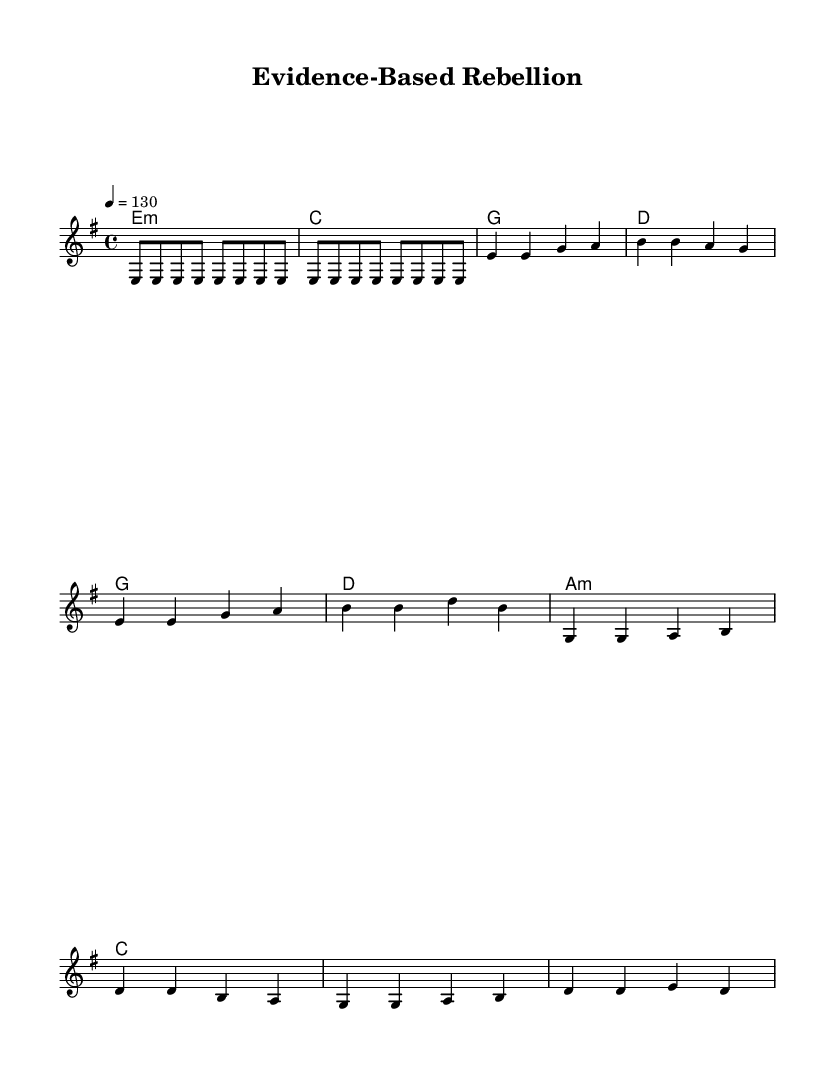What is the key signature of this music? The key signature is indicated at the beginning of the score, which shows that the music is in E minor. This is determined by identifying that there is one sharp (F#), typical for E minor.
Answer: E minor What is the time signature of this music? The time signature is presented as a fraction at the beginning of the score. It is written as 4/4, meaning there are four beats in each measure and the quarter note receives one beat.
Answer: 4/4 What is the tempo marking of this music? The tempo marking is found at the beginning of the score, specifically indicated as "4 = 130". This means there are 130 quarter note beats per minute, guiding the speed of the performance.
Answer: 130 What are the first two chords in the verse? The first two chords in the verse are found in the chord mode section associated with the verse. They are E minor followed by C major, which are labeled at the beginning of the respective measures.
Answer: E minor, C major How many measures does the chorus have? To determine this, one counts the bars in the chorus section, which is notated above the chorus lyrics. The chorus consists of four measures total, as there are four distinct rhythmic patterns before it repeats.
Answer: 4 What is the central theme conveyed in the lyrics of this piece? The lyrics express a strong sentiment against pseudoscience and misinformation, urging listeners to support scientific truth and reject false claims and miraculous cures. This thematic expression is reflected in the repeated phrases within the lyrics.
Answer: Support for science What style of music does this score represent? The score is designed with a hard rock structure and central lyrical content that critiques pseudoscience; it follows typical rock conventions with the use of electric guitar riffs and strong rhythmic sections.
Answer: Hard rock 